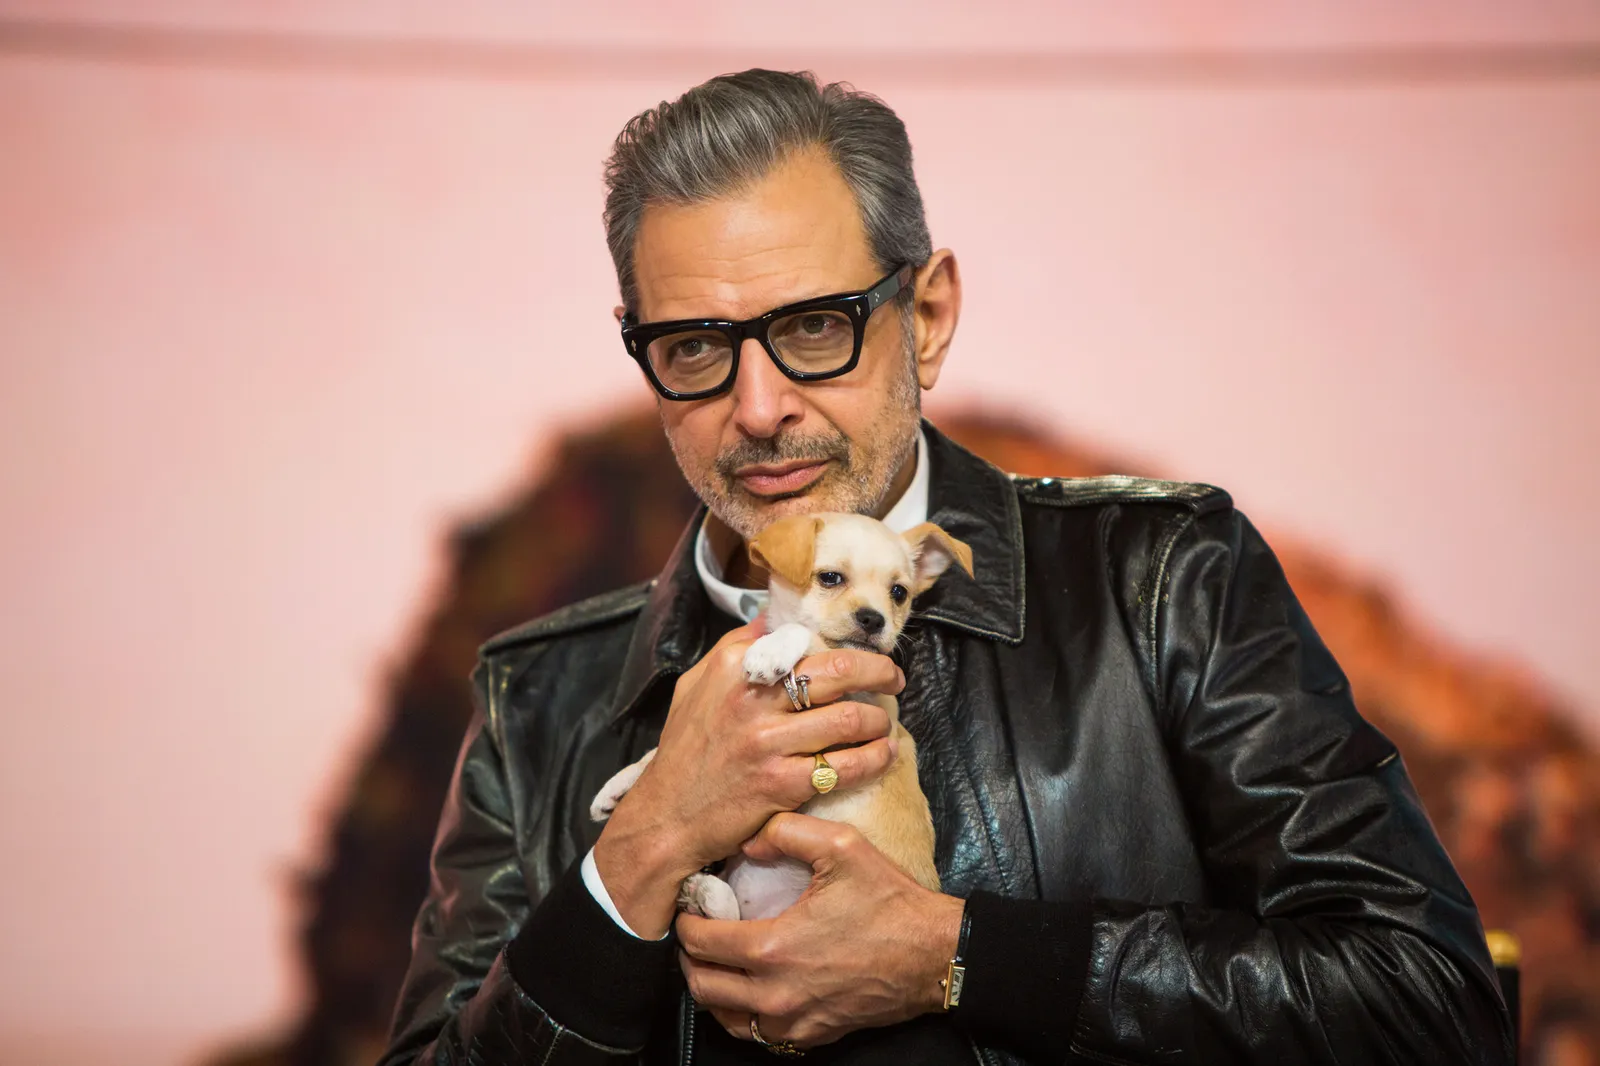How might the subject and the puppy be connected in a realistic everyday scenario? In a realistic everyday scenario, the subject could be a busy actor who finds solace in the simple joys of pet companionship. After long days on set, he cherishes the moments spent with his puppy, walking through parks, playing fetch, or simply unwinding at home. The puppy, in turn, offers unconditional love and a sense of normalcy amidst the actor’s hectic life, making each day brighter and more meaningful. Describe a short scene capturing their daily routine. Every morning, while the city still sleeps, the actor and his puppy step out for a quiet walk. The serene streets and the gentle rustling of leaves offer a perfect start to their day. As they walk, the actor rehearses lines under his breath while the puppy, ever curious, sniffs around and occasionally barks at passing squirrels. After their walk, they return to a cozy kitchen where the actor brews his coffee and fills the puppy's bowl. Together, they enjoy a peaceful breakfast before the actor heads off to his busy day, leaving the puppy with a gentle pat and a promise to return soon. 